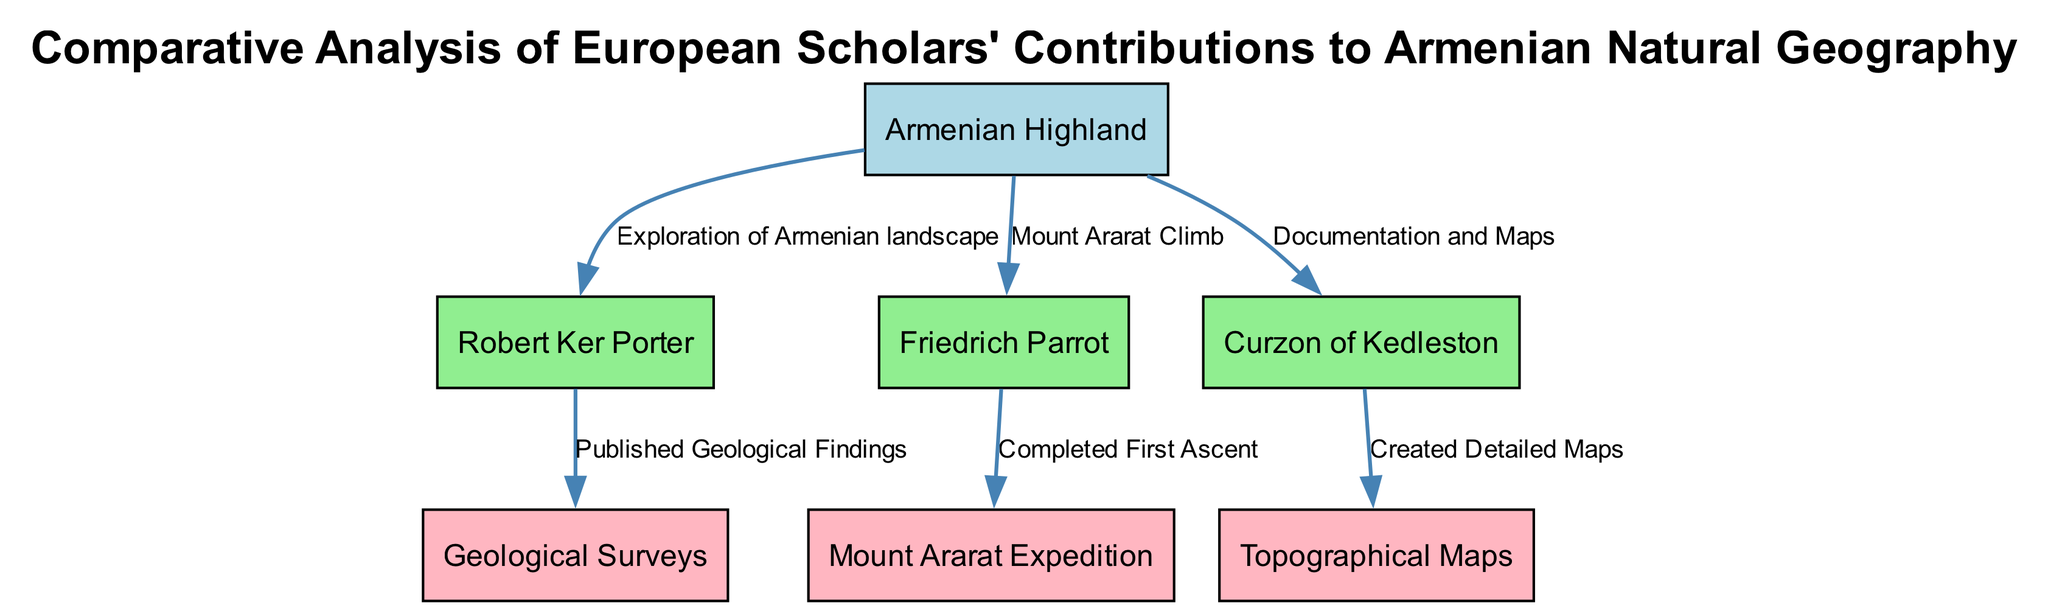What is the primary geographical feature highlighted in the diagram? The diagram emphasizes the "Armenian Highland" as the central geographical feature connecting various scholars and their contributions. It is identified as such in the node labeled "Armenian Highland."
Answer: Armenian Highland Who conducted the first ascent of Mount Ararat? The edge labeled "Completed First Ascent" connects Friedrich Parrot to the node "Mount Ararat Expedition," indicating that Friedrich Parrot is recognized for completing the first ascent of Mount Ararat.
Answer: Friedrich Parrot How many scholars are represented in the diagram? By counting the nodes labeled as scholars, we find three (Robert Ker Porter, Friedrich Parrot, Curzon of Kedleston) in the diagram, indicating that there are three scholars represented.
Answer: 3 What type of contribution did Robert Ker Porter make regarding geological findings? The relationship labeled "Published Geological Findings" connects Robert Ker Porter to the contribution node "Geological Surveys," indicating that his contribution pertains to geological findings.
Answer: Geological Surveys Which scholar is associated with creating detailed maps of the Armenian Highland? The edge labeled "Created Detailed Maps" connects Curzon of Kedleston to the node "Topographical Maps," indicating that Curzon of Kedleston is responsible for creating detailed maps.
Answer: Curzon of Kedleston What is the total number of contributions linked to the Armenian Highland? There are a total of three contribution nodes connected to the Armenian Highland (Geological Surveys, Mount Ararat Expedition, and Topographical Maps), thus indicating three contributions linked to it.
Answer: 3 What type of exploration is Robert Ker Porter noted for in the diagram? The diagram highlights Robert Ker Porter primarily for the "Exploration of Armenian landscape," linking him directly to the Armenian Highland node through this relationship.
Answer: Exploration of Armenian landscape Which relationship is described between Friedrich Parrot and the Mount Ararat? The relationship labeled "Mount Ararat Climb" indicates the connection between Friedrich Parrot and his significant action in relation to Mount Ararat, demonstrating his involvement in climbing it.
Answer: Mount Ararat Climb 